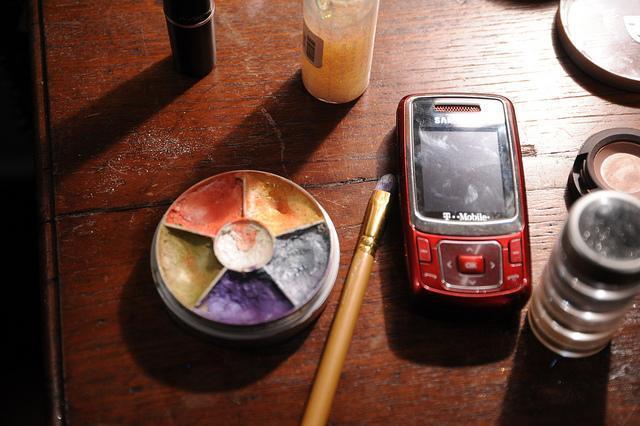How many bottles are visible?
Give a very brief answer. 1. How many people are in the picture?
Give a very brief answer. 0. 